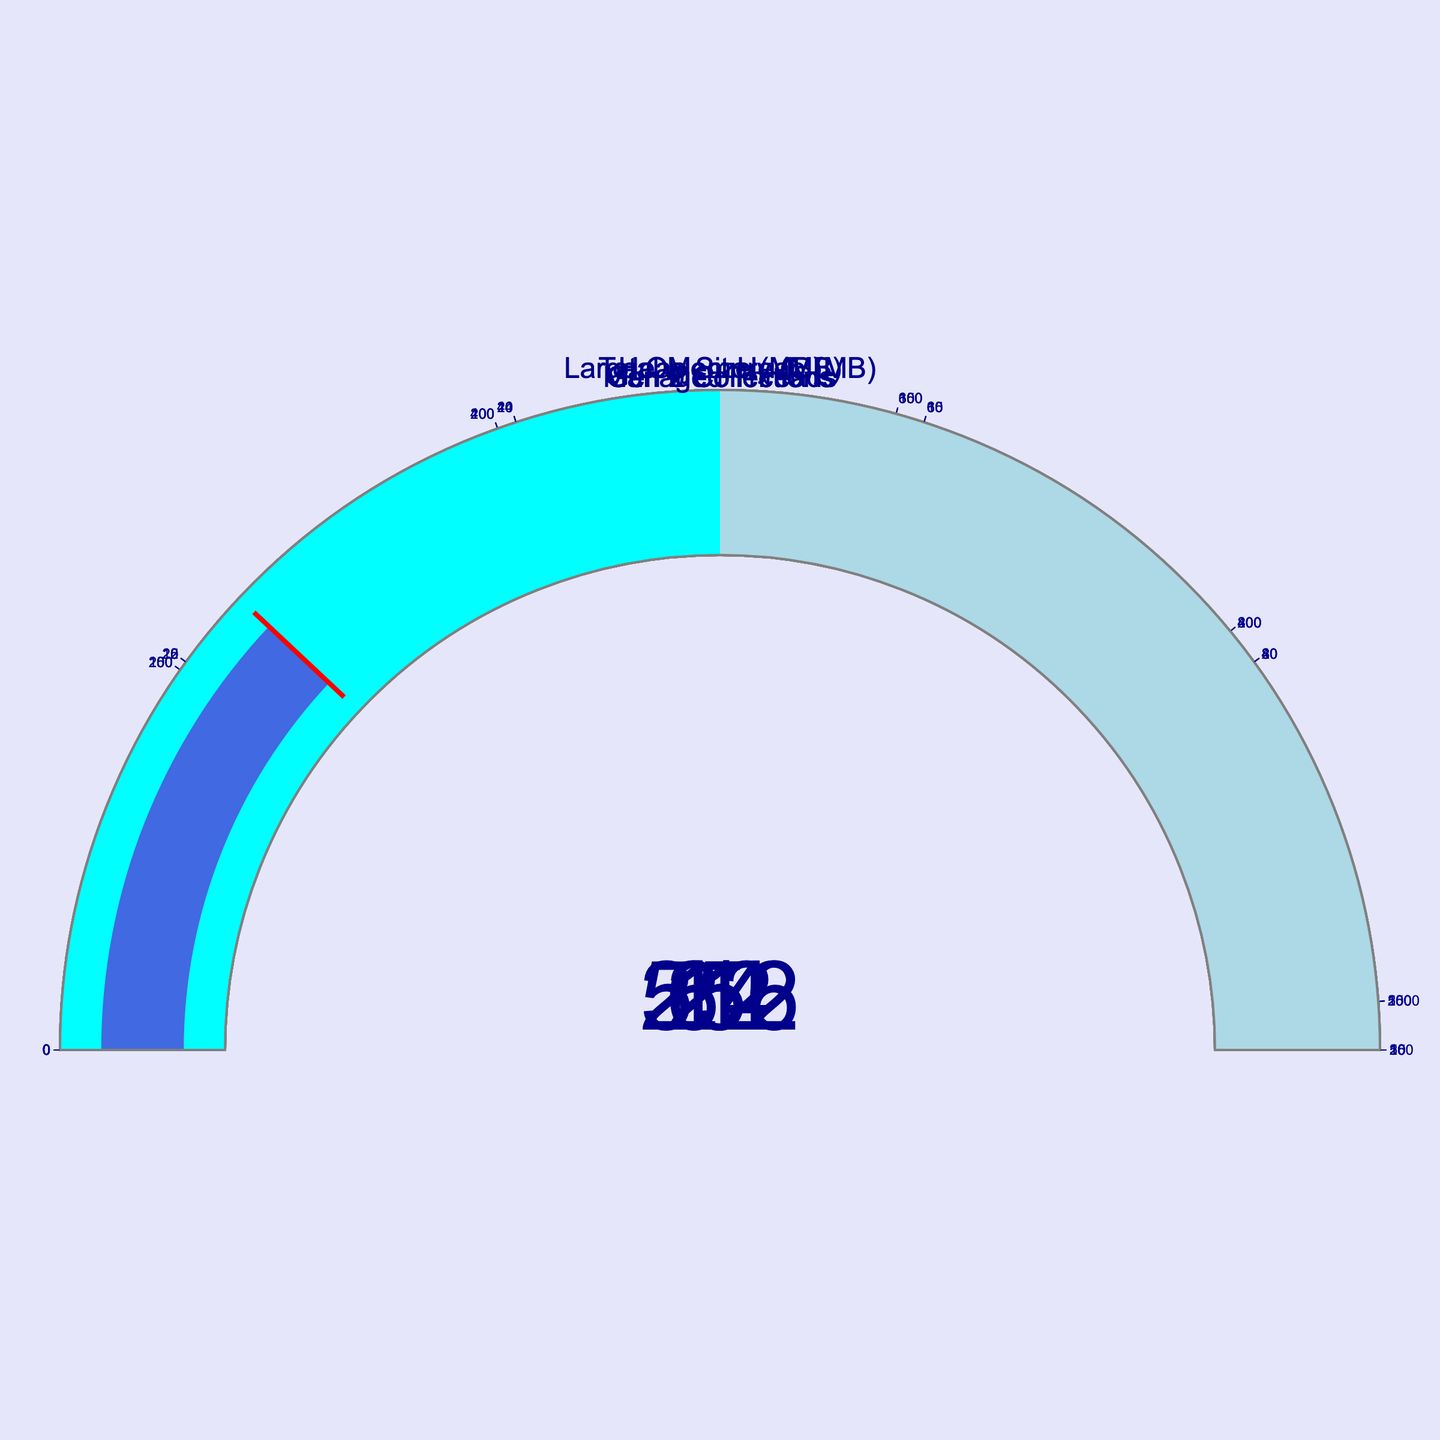What is the maximum value for the Total Memory gauge? The Total Memory gauge shows a value of 512 MB, and according to the axis labels, the maximum value is 1024 MB.
Answer: 1024 MB How many generations of garbage collections are shown in the figure? The figure includes separate gauges for Gen 0 Collections, Gen 1 Collections, and Gen 2 Collections, showing three types of garbage collections.
Answer: 3 Which has a higher value, the Large Object Heap or Gen 0 Collections? The Large Object Heap has a value of 64 MB, while Gen 0 Collections have a value of 12. 64 is greater than 12.
Answer: Large Object Heap What is the sum of values for Managed Threads and Gen 1 Collections? Managed Threads have a value of 24 and Gen 1 Collections have a value of 5. Adding these values gives 24 + 5 = 29.
Answer: 29 Compare the values of the Large Object Heap and Heap Size. Which is greater? The Large Object Heap has a value of 64 MB, while the Heap Size is 256 MB. 256 is greater than 64.
Answer: Heap Size What visual color indicates values beyond the halfway mark for all gauges? The steps in the gauge visual show that values beyond the halfway mark are colored light blue.
Answer: light blue How many MB of Total Memory is unused if the gauge shows 512 MB used and the maximum is 1024 MB? The Total Memory gauge shows that 512 MB is used, and with a maximum of 1024 MB, the unused memory is 1024 - 512 = 512 MB.
Answer: 512 MB What proportion of the MaxValue has the Gen 2 Collections reached? Gen 2 Collections show a value of 1 out of a maximum of 10. The proportion is 1/10, which is 0.1 or 10%.
Answer: 10% Which gauge shows the smallest numeric value? The gauge showing the smallest numeric value is the Gen 2 Collections, with a value of 1.
Answer: Gen 2 Collections How does the value of Heap Size compare to half its MaxValue? The Heap Size shows a value of 256 MB. Half its MaxValue is 512 MB / 2, which is 256 MB. The value exactly equals half of its MaxValue.
Answer: Equal to half 